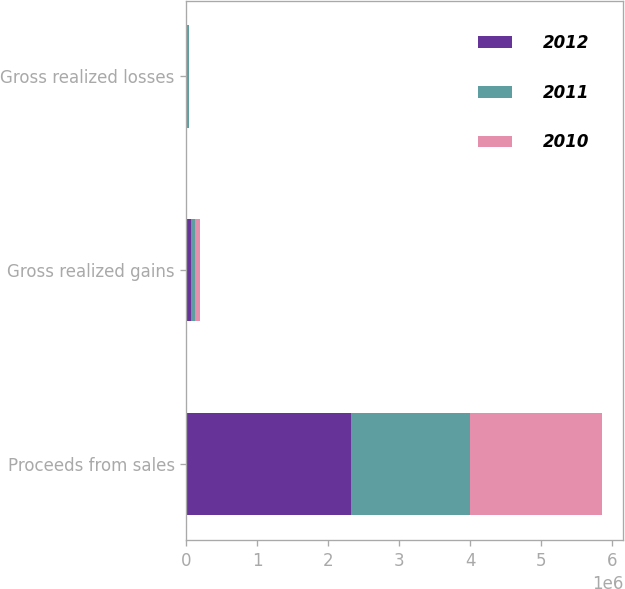<chart> <loc_0><loc_0><loc_500><loc_500><stacked_bar_chart><ecel><fcel>Proceeds from sales<fcel>Gross realized gains<fcel>Gross realized losses<nl><fcel>2012<fcel>2.31454e+06<fcel>68697<fcel>12597<nl><fcel>2011<fcel>1.67955e+06<fcel>57120<fcel>20925<nl><fcel>2010<fcel>1.8678e+06<fcel>65861<fcel>8286<nl></chart> 